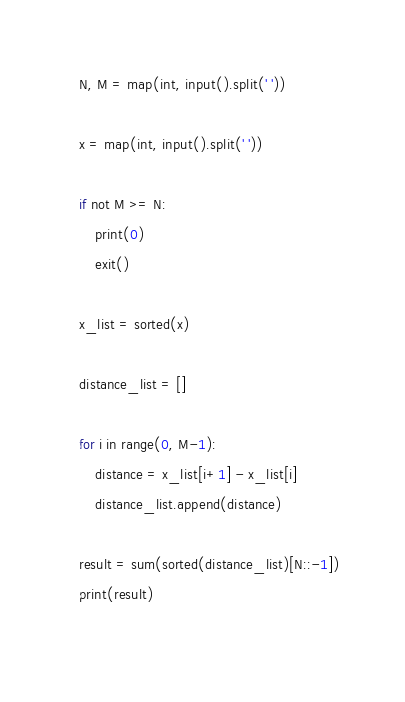Convert code to text. <code><loc_0><loc_0><loc_500><loc_500><_Python_>N, M = map(int, input().split(' '))

x = map(int, input().split(' '))

if not M >= N:
    print(0)
    exit()

x_list = sorted(x)

distance_list = []

for i in range(0, M-1):
    distance = x_list[i+1] - x_list[i]
    distance_list.append(distance)

result = sum(sorted(distance_list)[N::-1])
print(result)
 </code> 